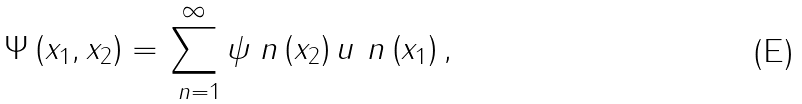Convert formula to latex. <formula><loc_0><loc_0><loc_500><loc_500>\Psi \left ( x _ { 1 } , x _ { 2 } \right ) = \sum _ { \ n = 1 } ^ { \infty } \psi _ { \ } n \left ( x _ { 2 } \right ) u _ { \ } n \left ( x _ { 1 } \right ) ,</formula> 